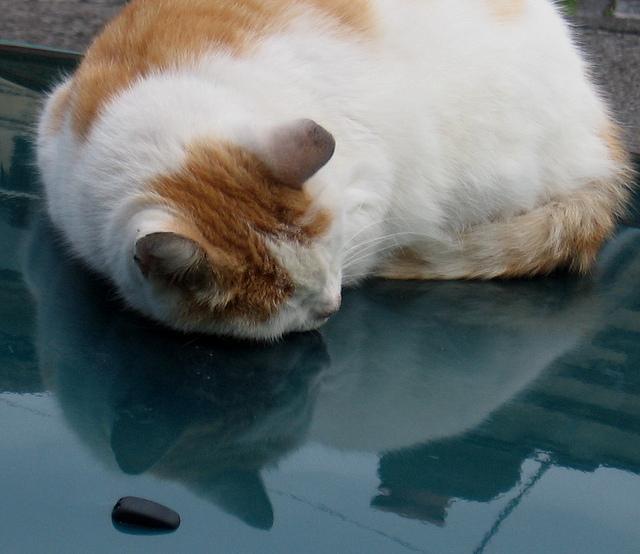How many people are wearing a pink shirt?
Give a very brief answer. 0. 